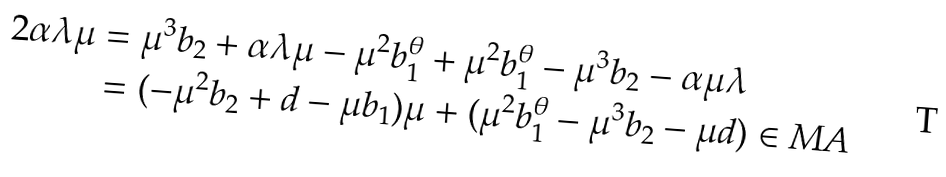<formula> <loc_0><loc_0><loc_500><loc_500>2 \alpha \lambda \mu & = \mu ^ { 3 } b _ { 2 } + \alpha \lambda \mu - \mu ^ { 2 } b _ { 1 } ^ { \theta } + \mu ^ { 2 } b _ { 1 } ^ { \theta } - \mu ^ { 3 } b _ { 2 } - \alpha \mu \lambda \\ & = ( - \mu ^ { 2 } b _ { 2 } + d - \mu b _ { 1 } ) \mu + ( \mu ^ { 2 } b _ { 1 } ^ { \theta } - \mu ^ { 3 } b _ { 2 } - \mu d ) \in M A</formula> 